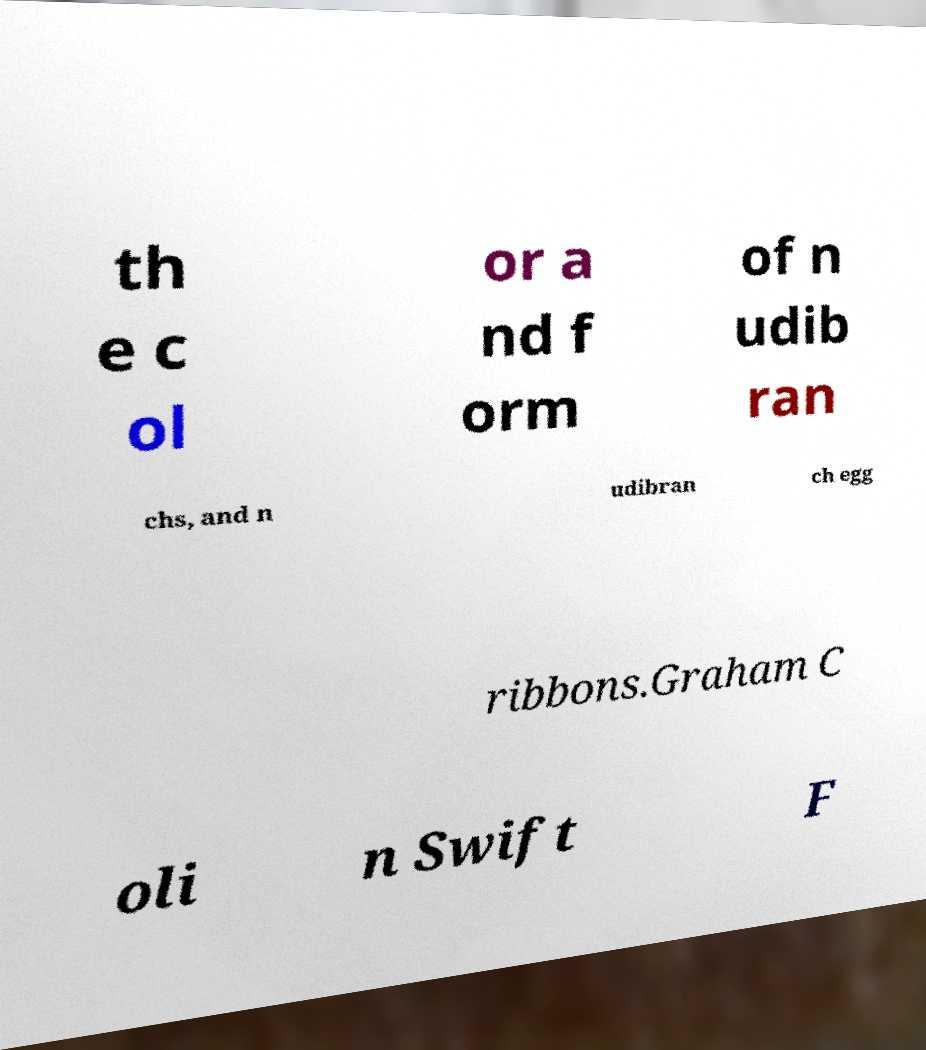Please identify and transcribe the text found in this image. th e c ol or a nd f orm of n udib ran chs, and n udibran ch egg ribbons.Graham C oli n Swift F 